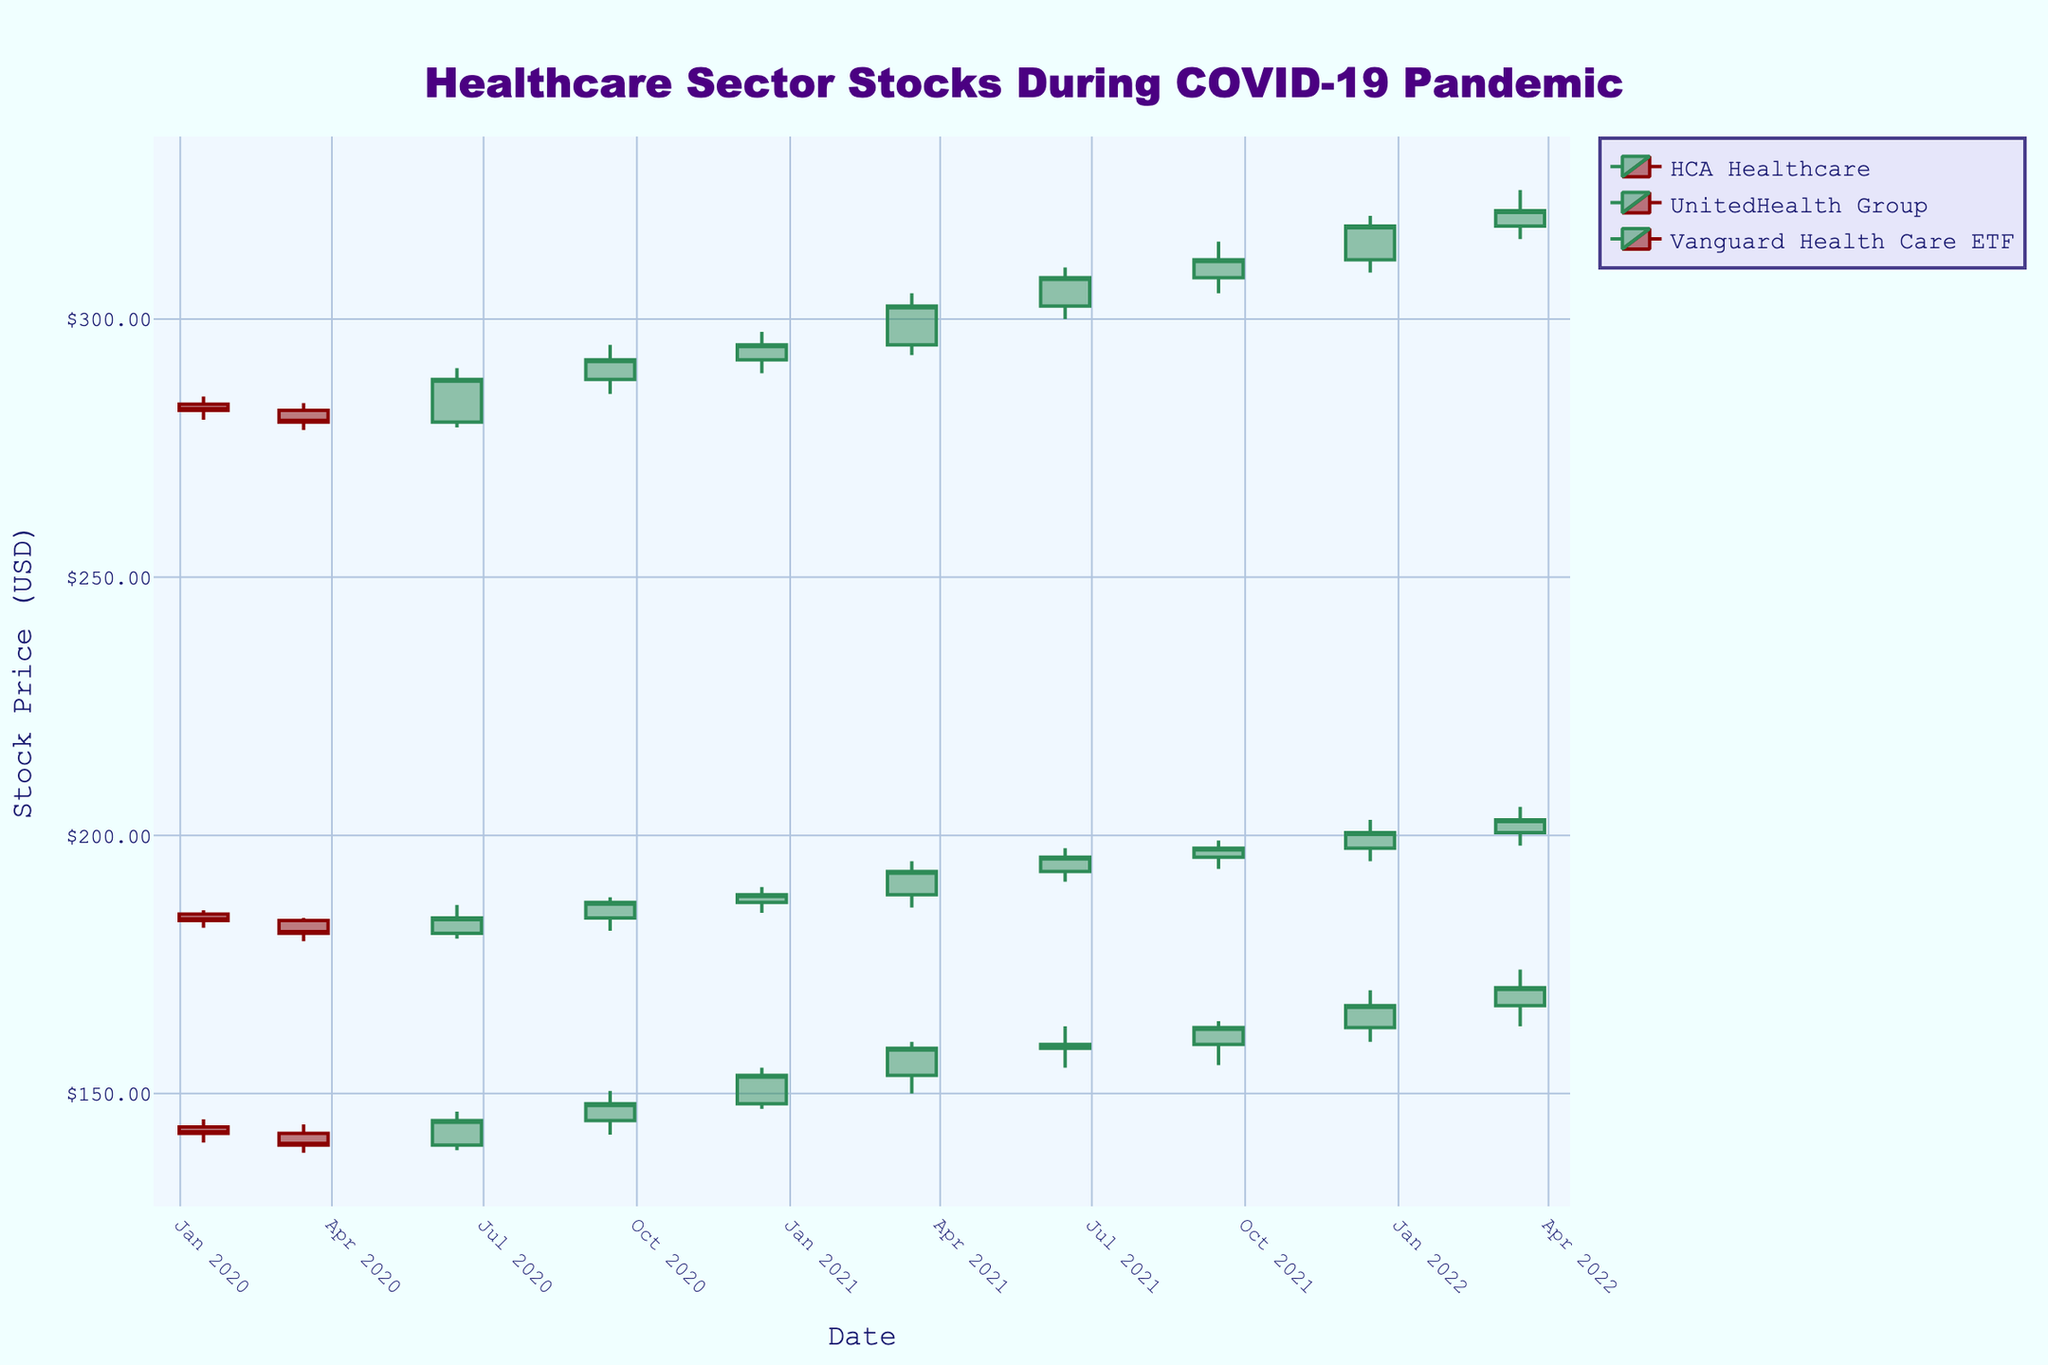What is the title of the figure? The title is written at the top of the figure in a large, distinct font. It reads "Healthcare Sector Stocks During COVID-19 Pandemic".
Answer: Healthcare Sector Stocks During COVID-19 Pandemic What is the closing price of HCA Healthcare on December 15, 2021? To find the closing price, locate the candlestick for HCA Healthcare on December 15, 2021. The closing price is at the top of the candlestick if the price increased that day, which it did as indicated by the green color.
Answer: 167.00 Which healthcare stock had the highest closing price in the dataset? By examining the closing prices of each stock throughout the dataset, you can see that UnitedHealth Group had the highest closing price, specifically in multiple dates including 2022-03-15 where it reached 321.00.
Answer: UnitedHealth Group How did the stock prices of UnitedHealth Group compare between March 15, 2020, and March 15, 2021? To compare, find the closing prices for UnitedHealth Group on these dates. On March 15, 2020, the closing price was 280.05, and on March 15, 2021, it was 302.50. The price increased by 22.45.
Answer: Increased by 22.45 What trend can be observed for HCA Healthcare’s stock price from March 15, 2020, to March 15, 2022? Identify the closing prices for HCA Healthcare on these dates: March 15, 2020, was 140.00, and March 15, 2022, was 170.50. Therefore, the trend over this period shows a gradual increase.
Answer: Increased Which date had the highest trading volume for HCA Healthcare, and what was the volume? Check the volume data for HCA Healthcare. The highest trading volume is on December 15, 2021, at 2,700,000 shares.
Answer: December 15, 2021, with 2,700,000 shares What are the lowest and highest shadow lengths of the candlesticks for Vanguard Health Care ETF on June 15, 2020? The lowest shadow length is the difference between the open and low prices, and the highest shadow length is the difference between the high and close prices on June 15, 2020. These values are (181.00 - 180.00 = 1.00) and (186.50 - 184.00 = 2.50), respectively.
Answer: 1.00 (low), 2.50 (high) How did the trading volume of Vanguard Health Care ETF change from January 15, 2020, to March 15, 2020? In January 2020, the trading volume was 900,000; in March 2020, it was 920,000. There was an increase of 20,000.
Answer: Increased by 20,000 Did any healthcare stock show a predominantly decreasing trend during 2020? Observe the candlestick colors and price directions for each stock during 2020. HCA Healthcare's stock generally appears to decrease, especially from January to June.
Answer: Yes, HCA Healthcare 